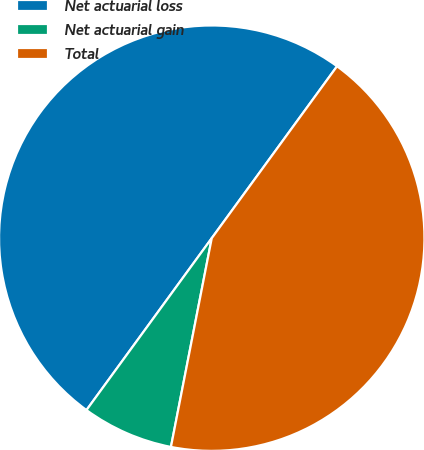<chart> <loc_0><loc_0><loc_500><loc_500><pie_chart><fcel>Net actuarial loss<fcel>Net actuarial gain<fcel>Total<nl><fcel>50.0%<fcel>6.95%<fcel>43.05%<nl></chart> 